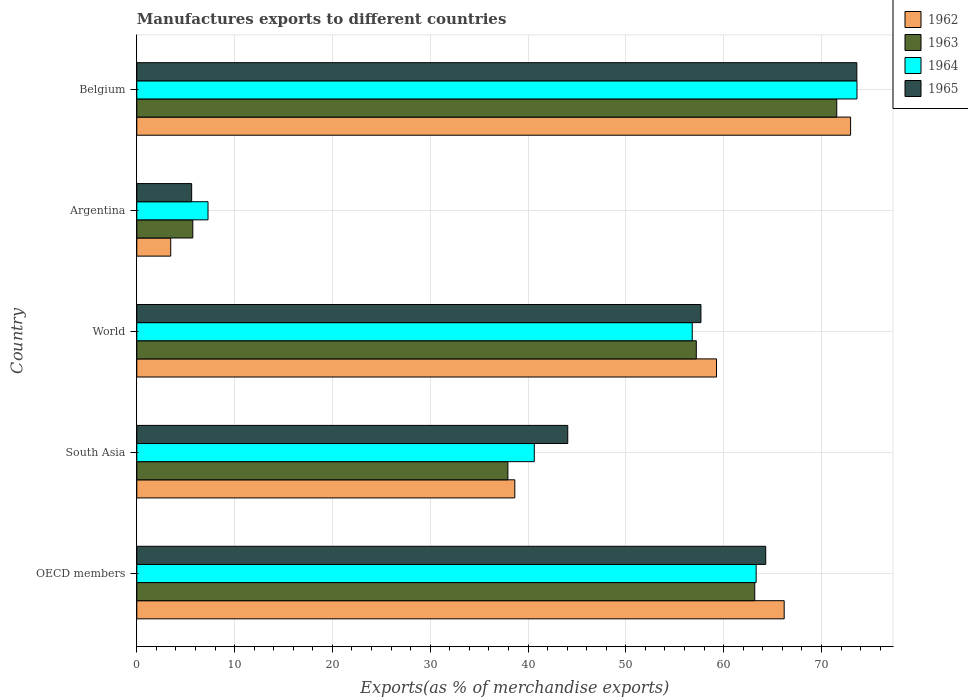How many different coloured bars are there?
Provide a succinct answer. 4. How many groups of bars are there?
Offer a very short reply. 5. Are the number of bars per tick equal to the number of legend labels?
Keep it short and to the point. Yes. How many bars are there on the 5th tick from the top?
Your answer should be compact. 4. How many bars are there on the 3rd tick from the bottom?
Your answer should be compact. 4. In how many cases, is the number of bars for a given country not equal to the number of legend labels?
Your response must be concise. 0. What is the percentage of exports to different countries in 1965 in Belgium?
Make the answer very short. 73.62. Across all countries, what is the maximum percentage of exports to different countries in 1963?
Give a very brief answer. 71.56. Across all countries, what is the minimum percentage of exports to different countries in 1964?
Give a very brief answer. 7.28. In which country was the percentage of exports to different countries in 1965 minimum?
Make the answer very short. Argentina. What is the total percentage of exports to different countries in 1964 in the graph?
Make the answer very short. 241.67. What is the difference between the percentage of exports to different countries in 1963 in Argentina and that in South Asia?
Your answer should be very brief. -32.21. What is the difference between the percentage of exports to different countries in 1965 in OECD members and the percentage of exports to different countries in 1964 in Argentina?
Offer a terse response. 57.02. What is the average percentage of exports to different countries in 1964 per country?
Offer a terse response. 48.33. What is the difference between the percentage of exports to different countries in 1962 and percentage of exports to different countries in 1965 in Belgium?
Ensure brevity in your answer.  -0.64. In how many countries, is the percentage of exports to different countries in 1965 greater than 22 %?
Offer a terse response. 4. What is the ratio of the percentage of exports to different countries in 1962 in Belgium to that in World?
Your response must be concise. 1.23. Is the difference between the percentage of exports to different countries in 1962 in Argentina and OECD members greater than the difference between the percentage of exports to different countries in 1965 in Argentina and OECD members?
Keep it short and to the point. No. What is the difference between the highest and the second highest percentage of exports to different countries in 1962?
Make the answer very short. 6.79. What is the difference between the highest and the lowest percentage of exports to different countries in 1963?
Give a very brief answer. 65.84. In how many countries, is the percentage of exports to different countries in 1962 greater than the average percentage of exports to different countries in 1962 taken over all countries?
Ensure brevity in your answer.  3. Is it the case that in every country, the sum of the percentage of exports to different countries in 1962 and percentage of exports to different countries in 1964 is greater than the sum of percentage of exports to different countries in 1965 and percentage of exports to different countries in 1963?
Keep it short and to the point. No. What does the 2nd bar from the top in Argentina represents?
Make the answer very short. 1964. What does the 4th bar from the bottom in OECD members represents?
Provide a succinct answer. 1965. Is it the case that in every country, the sum of the percentage of exports to different countries in 1963 and percentage of exports to different countries in 1962 is greater than the percentage of exports to different countries in 1964?
Give a very brief answer. Yes. Are all the bars in the graph horizontal?
Ensure brevity in your answer.  Yes. How many countries are there in the graph?
Offer a very short reply. 5. What is the difference between two consecutive major ticks on the X-axis?
Keep it short and to the point. 10. Are the values on the major ticks of X-axis written in scientific E-notation?
Offer a very short reply. No. Does the graph contain grids?
Give a very brief answer. Yes. Where does the legend appear in the graph?
Ensure brevity in your answer.  Top right. What is the title of the graph?
Ensure brevity in your answer.  Manufactures exports to different countries. Does "2002" appear as one of the legend labels in the graph?
Give a very brief answer. No. What is the label or title of the X-axis?
Offer a very short reply. Exports(as % of merchandise exports). What is the label or title of the Y-axis?
Your answer should be very brief. Country. What is the Exports(as % of merchandise exports) in 1962 in OECD members?
Your answer should be very brief. 66.19. What is the Exports(as % of merchandise exports) of 1963 in OECD members?
Ensure brevity in your answer.  63.18. What is the Exports(as % of merchandise exports) of 1964 in OECD members?
Provide a short and direct response. 63.32. What is the Exports(as % of merchandise exports) in 1965 in OECD members?
Keep it short and to the point. 64.3. What is the Exports(as % of merchandise exports) of 1962 in South Asia?
Your answer should be compact. 38.65. What is the Exports(as % of merchandise exports) in 1963 in South Asia?
Provide a short and direct response. 37.94. What is the Exports(as % of merchandise exports) in 1964 in South Asia?
Your response must be concise. 40.64. What is the Exports(as % of merchandise exports) in 1965 in South Asia?
Keep it short and to the point. 44.06. What is the Exports(as % of merchandise exports) of 1962 in World?
Provide a short and direct response. 59.27. What is the Exports(as % of merchandise exports) in 1963 in World?
Offer a terse response. 57.2. What is the Exports(as % of merchandise exports) of 1964 in World?
Your response must be concise. 56.79. What is the Exports(as % of merchandise exports) of 1965 in World?
Keep it short and to the point. 57.68. What is the Exports(as % of merchandise exports) of 1962 in Argentina?
Ensure brevity in your answer.  3.47. What is the Exports(as % of merchandise exports) in 1963 in Argentina?
Provide a short and direct response. 5.73. What is the Exports(as % of merchandise exports) of 1964 in Argentina?
Offer a very short reply. 7.28. What is the Exports(as % of merchandise exports) in 1965 in Argentina?
Your response must be concise. 5.61. What is the Exports(as % of merchandise exports) in 1962 in Belgium?
Provide a short and direct response. 72.98. What is the Exports(as % of merchandise exports) in 1963 in Belgium?
Provide a short and direct response. 71.56. What is the Exports(as % of merchandise exports) of 1964 in Belgium?
Your response must be concise. 73.63. What is the Exports(as % of merchandise exports) in 1965 in Belgium?
Make the answer very short. 73.62. Across all countries, what is the maximum Exports(as % of merchandise exports) of 1962?
Provide a short and direct response. 72.98. Across all countries, what is the maximum Exports(as % of merchandise exports) in 1963?
Provide a short and direct response. 71.56. Across all countries, what is the maximum Exports(as % of merchandise exports) in 1964?
Offer a terse response. 73.63. Across all countries, what is the maximum Exports(as % of merchandise exports) of 1965?
Offer a terse response. 73.62. Across all countries, what is the minimum Exports(as % of merchandise exports) of 1962?
Ensure brevity in your answer.  3.47. Across all countries, what is the minimum Exports(as % of merchandise exports) in 1963?
Provide a short and direct response. 5.73. Across all countries, what is the minimum Exports(as % of merchandise exports) in 1964?
Your response must be concise. 7.28. Across all countries, what is the minimum Exports(as % of merchandise exports) of 1965?
Offer a very short reply. 5.61. What is the total Exports(as % of merchandise exports) in 1962 in the graph?
Make the answer very short. 240.56. What is the total Exports(as % of merchandise exports) of 1963 in the graph?
Keep it short and to the point. 235.61. What is the total Exports(as % of merchandise exports) in 1964 in the graph?
Keep it short and to the point. 241.67. What is the total Exports(as % of merchandise exports) in 1965 in the graph?
Make the answer very short. 245.27. What is the difference between the Exports(as % of merchandise exports) in 1962 in OECD members and that in South Asia?
Offer a terse response. 27.54. What is the difference between the Exports(as % of merchandise exports) of 1963 in OECD members and that in South Asia?
Offer a very short reply. 25.24. What is the difference between the Exports(as % of merchandise exports) in 1964 in OECD members and that in South Asia?
Your answer should be very brief. 22.68. What is the difference between the Exports(as % of merchandise exports) of 1965 in OECD members and that in South Asia?
Offer a very short reply. 20.24. What is the difference between the Exports(as % of merchandise exports) of 1962 in OECD members and that in World?
Your response must be concise. 6.92. What is the difference between the Exports(as % of merchandise exports) of 1963 in OECD members and that in World?
Give a very brief answer. 5.98. What is the difference between the Exports(as % of merchandise exports) of 1964 in OECD members and that in World?
Your answer should be compact. 6.53. What is the difference between the Exports(as % of merchandise exports) in 1965 in OECD members and that in World?
Offer a terse response. 6.63. What is the difference between the Exports(as % of merchandise exports) in 1962 in OECD members and that in Argentina?
Offer a terse response. 62.72. What is the difference between the Exports(as % of merchandise exports) of 1963 in OECD members and that in Argentina?
Your response must be concise. 57.46. What is the difference between the Exports(as % of merchandise exports) of 1964 in OECD members and that in Argentina?
Keep it short and to the point. 56.04. What is the difference between the Exports(as % of merchandise exports) of 1965 in OECD members and that in Argentina?
Offer a terse response. 58.69. What is the difference between the Exports(as % of merchandise exports) of 1962 in OECD members and that in Belgium?
Provide a succinct answer. -6.79. What is the difference between the Exports(as % of merchandise exports) of 1963 in OECD members and that in Belgium?
Make the answer very short. -8.38. What is the difference between the Exports(as % of merchandise exports) in 1964 in OECD members and that in Belgium?
Offer a terse response. -10.31. What is the difference between the Exports(as % of merchandise exports) of 1965 in OECD members and that in Belgium?
Give a very brief answer. -9.32. What is the difference between the Exports(as % of merchandise exports) in 1962 in South Asia and that in World?
Keep it short and to the point. -20.62. What is the difference between the Exports(as % of merchandise exports) of 1963 in South Asia and that in World?
Give a very brief answer. -19.26. What is the difference between the Exports(as % of merchandise exports) of 1964 in South Asia and that in World?
Provide a succinct answer. -16.15. What is the difference between the Exports(as % of merchandise exports) of 1965 in South Asia and that in World?
Give a very brief answer. -13.62. What is the difference between the Exports(as % of merchandise exports) of 1962 in South Asia and that in Argentina?
Provide a short and direct response. 35.18. What is the difference between the Exports(as % of merchandise exports) of 1963 in South Asia and that in Argentina?
Your response must be concise. 32.21. What is the difference between the Exports(as % of merchandise exports) in 1964 in South Asia and that in Argentina?
Provide a short and direct response. 33.36. What is the difference between the Exports(as % of merchandise exports) of 1965 in South Asia and that in Argentina?
Offer a very short reply. 38.45. What is the difference between the Exports(as % of merchandise exports) in 1962 in South Asia and that in Belgium?
Make the answer very short. -34.33. What is the difference between the Exports(as % of merchandise exports) in 1963 in South Asia and that in Belgium?
Provide a succinct answer. -33.62. What is the difference between the Exports(as % of merchandise exports) in 1964 in South Asia and that in Belgium?
Offer a very short reply. -32.99. What is the difference between the Exports(as % of merchandise exports) in 1965 in South Asia and that in Belgium?
Make the answer very short. -29.56. What is the difference between the Exports(as % of merchandise exports) in 1962 in World and that in Argentina?
Offer a terse response. 55.8. What is the difference between the Exports(as % of merchandise exports) of 1963 in World and that in Argentina?
Provide a short and direct response. 51.48. What is the difference between the Exports(as % of merchandise exports) of 1964 in World and that in Argentina?
Offer a very short reply. 49.51. What is the difference between the Exports(as % of merchandise exports) of 1965 in World and that in Argentina?
Offer a terse response. 52.07. What is the difference between the Exports(as % of merchandise exports) in 1962 in World and that in Belgium?
Provide a short and direct response. -13.71. What is the difference between the Exports(as % of merchandise exports) in 1963 in World and that in Belgium?
Offer a terse response. -14.36. What is the difference between the Exports(as % of merchandise exports) in 1964 in World and that in Belgium?
Provide a short and direct response. -16.84. What is the difference between the Exports(as % of merchandise exports) of 1965 in World and that in Belgium?
Your response must be concise. -15.94. What is the difference between the Exports(as % of merchandise exports) in 1962 in Argentina and that in Belgium?
Make the answer very short. -69.51. What is the difference between the Exports(as % of merchandise exports) in 1963 in Argentina and that in Belgium?
Provide a short and direct response. -65.84. What is the difference between the Exports(as % of merchandise exports) of 1964 in Argentina and that in Belgium?
Offer a very short reply. -66.35. What is the difference between the Exports(as % of merchandise exports) of 1965 in Argentina and that in Belgium?
Your answer should be compact. -68.01. What is the difference between the Exports(as % of merchandise exports) in 1962 in OECD members and the Exports(as % of merchandise exports) in 1963 in South Asia?
Ensure brevity in your answer.  28.25. What is the difference between the Exports(as % of merchandise exports) of 1962 in OECD members and the Exports(as % of merchandise exports) of 1964 in South Asia?
Offer a very short reply. 25.55. What is the difference between the Exports(as % of merchandise exports) of 1962 in OECD members and the Exports(as % of merchandise exports) of 1965 in South Asia?
Your response must be concise. 22.13. What is the difference between the Exports(as % of merchandise exports) of 1963 in OECD members and the Exports(as % of merchandise exports) of 1964 in South Asia?
Make the answer very short. 22.54. What is the difference between the Exports(as % of merchandise exports) in 1963 in OECD members and the Exports(as % of merchandise exports) in 1965 in South Asia?
Give a very brief answer. 19.12. What is the difference between the Exports(as % of merchandise exports) of 1964 in OECD members and the Exports(as % of merchandise exports) of 1965 in South Asia?
Make the answer very short. 19.26. What is the difference between the Exports(as % of merchandise exports) of 1962 in OECD members and the Exports(as % of merchandise exports) of 1963 in World?
Give a very brief answer. 8.99. What is the difference between the Exports(as % of merchandise exports) of 1962 in OECD members and the Exports(as % of merchandise exports) of 1964 in World?
Offer a terse response. 9.4. What is the difference between the Exports(as % of merchandise exports) of 1962 in OECD members and the Exports(as % of merchandise exports) of 1965 in World?
Your answer should be very brief. 8.51. What is the difference between the Exports(as % of merchandise exports) of 1963 in OECD members and the Exports(as % of merchandise exports) of 1964 in World?
Provide a short and direct response. 6.39. What is the difference between the Exports(as % of merchandise exports) in 1963 in OECD members and the Exports(as % of merchandise exports) in 1965 in World?
Your answer should be very brief. 5.5. What is the difference between the Exports(as % of merchandise exports) in 1964 in OECD members and the Exports(as % of merchandise exports) in 1965 in World?
Make the answer very short. 5.65. What is the difference between the Exports(as % of merchandise exports) in 1962 in OECD members and the Exports(as % of merchandise exports) in 1963 in Argentina?
Your answer should be compact. 60.46. What is the difference between the Exports(as % of merchandise exports) of 1962 in OECD members and the Exports(as % of merchandise exports) of 1964 in Argentina?
Give a very brief answer. 58.91. What is the difference between the Exports(as % of merchandise exports) of 1962 in OECD members and the Exports(as % of merchandise exports) of 1965 in Argentina?
Your answer should be compact. 60.58. What is the difference between the Exports(as % of merchandise exports) in 1963 in OECD members and the Exports(as % of merchandise exports) in 1964 in Argentina?
Your response must be concise. 55.9. What is the difference between the Exports(as % of merchandise exports) of 1963 in OECD members and the Exports(as % of merchandise exports) of 1965 in Argentina?
Your response must be concise. 57.57. What is the difference between the Exports(as % of merchandise exports) of 1964 in OECD members and the Exports(as % of merchandise exports) of 1965 in Argentina?
Ensure brevity in your answer.  57.71. What is the difference between the Exports(as % of merchandise exports) in 1962 in OECD members and the Exports(as % of merchandise exports) in 1963 in Belgium?
Your response must be concise. -5.37. What is the difference between the Exports(as % of merchandise exports) in 1962 in OECD members and the Exports(as % of merchandise exports) in 1964 in Belgium?
Make the answer very short. -7.44. What is the difference between the Exports(as % of merchandise exports) in 1962 in OECD members and the Exports(as % of merchandise exports) in 1965 in Belgium?
Offer a very short reply. -7.43. What is the difference between the Exports(as % of merchandise exports) in 1963 in OECD members and the Exports(as % of merchandise exports) in 1964 in Belgium?
Your response must be concise. -10.45. What is the difference between the Exports(as % of merchandise exports) of 1963 in OECD members and the Exports(as % of merchandise exports) of 1965 in Belgium?
Give a very brief answer. -10.44. What is the difference between the Exports(as % of merchandise exports) of 1964 in OECD members and the Exports(as % of merchandise exports) of 1965 in Belgium?
Offer a terse response. -10.29. What is the difference between the Exports(as % of merchandise exports) of 1962 in South Asia and the Exports(as % of merchandise exports) of 1963 in World?
Your answer should be compact. -18.56. What is the difference between the Exports(as % of merchandise exports) of 1962 in South Asia and the Exports(as % of merchandise exports) of 1964 in World?
Your answer should be compact. -18.14. What is the difference between the Exports(as % of merchandise exports) of 1962 in South Asia and the Exports(as % of merchandise exports) of 1965 in World?
Your answer should be compact. -19.03. What is the difference between the Exports(as % of merchandise exports) in 1963 in South Asia and the Exports(as % of merchandise exports) in 1964 in World?
Provide a short and direct response. -18.85. What is the difference between the Exports(as % of merchandise exports) of 1963 in South Asia and the Exports(as % of merchandise exports) of 1965 in World?
Keep it short and to the point. -19.74. What is the difference between the Exports(as % of merchandise exports) in 1964 in South Asia and the Exports(as % of merchandise exports) in 1965 in World?
Ensure brevity in your answer.  -17.04. What is the difference between the Exports(as % of merchandise exports) in 1962 in South Asia and the Exports(as % of merchandise exports) in 1963 in Argentina?
Your answer should be compact. 32.92. What is the difference between the Exports(as % of merchandise exports) of 1962 in South Asia and the Exports(as % of merchandise exports) of 1964 in Argentina?
Your answer should be compact. 31.37. What is the difference between the Exports(as % of merchandise exports) of 1962 in South Asia and the Exports(as % of merchandise exports) of 1965 in Argentina?
Keep it short and to the point. 33.04. What is the difference between the Exports(as % of merchandise exports) of 1963 in South Asia and the Exports(as % of merchandise exports) of 1964 in Argentina?
Offer a terse response. 30.66. What is the difference between the Exports(as % of merchandise exports) of 1963 in South Asia and the Exports(as % of merchandise exports) of 1965 in Argentina?
Keep it short and to the point. 32.33. What is the difference between the Exports(as % of merchandise exports) of 1964 in South Asia and the Exports(as % of merchandise exports) of 1965 in Argentina?
Offer a terse response. 35.03. What is the difference between the Exports(as % of merchandise exports) of 1962 in South Asia and the Exports(as % of merchandise exports) of 1963 in Belgium?
Offer a terse response. -32.92. What is the difference between the Exports(as % of merchandise exports) in 1962 in South Asia and the Exports(as % of merchandise exports) in 1964 in Belgium?
Your response must be concise. -34.98. What is the difference between the Exports(as % of merchandise exports) in 1962 in South Asia and the Exports(as % of merchandise exports) in 1965 in Belgium?
Offer a terse response. -34.97. What is the difference between the Exports(as % of merchandise exports) of 1963 in South Asia and the Exports(as % of merchandise exports) of 1964 in Belgium?
Offer a very short reply. -35.69. What is the difference between the Exports(as % of merchandise exports) in 1963 in South Asia and the Exports(as % of merchandise exports) in 1965 in Belgium?
Provide a succinct answer. -35.68. What is the difference between the Exports(as % of merchandise exports) of 1964 in South Asia and the Exports(as % of merchandise exports) of 1965 in Belgium?
Ensure brevity in your answer.  -32.98. What is the difference between the Exports(as % of merchandise exports) of 1962 in World and the Exports(as % of merchandise exports) of 1963 in Argentina?
Your answer should be compact. 53.55. What is the difference between the Exports(as % of merchandise exports) in 1962 in World and the Exports(as % of merchandise exports) in 1964 in Argentina?
Provide a succinct answer. 51.99. What is the difference between the Exports(as % of merchandise exports) in 1962 in World and the Exports(as % of merchandise exports) in 1965 in Argentina?
Your answer should be very brief. 53.66. What is the difference between the Exports(as % of merchandise exports) of 1963 in World and the Exports(as % of merchandise exports) of 1964 in Argentina?
Offer a terse response. 49.92. What is the difference between the Exports(as % of merchandise exports) of 1963 in World and the Exports(as % of merchandise exports) of 1965 in Argentina?
Your answer should be compact. 51.59. What is the difference between the Exports(as % of merchandise exports) in 1964 in World and the Exports(as % of merchandise exports) in 1965 in Argentina?
Keep it short and to the point. 51.18. What is the difference between the Exports(as % of merchandise exports) in 1962 in World and the Exports(as % of merchandise exports) in 1963 in Belgium?
Your answer should be compact. -12.29. What is the difference between the Exports(as % of merchandise exports) of 1962 in World and the Exports(as % of merchandise exports) of 1964 in Belgium?
Provide a short and direct response. -14.36. What is the difference between the Exports(as % of merchandise exports) in 1962 in World and the Exports(as % of merchandise exports) in 1965 in Belgium?
Make the answer very short. -14.35. What is the difference between the Exports(as % of merchandise exports) of 1963 in World and the Exports(as % of merchandise exports) of 1964 in Belgium?
Ensure brevity in your answer.  -16.43. What is the difference between the Exports(as % of merchandise exports) in 1963 in World and the Exports(as % of merchandise exports) in 1965 in Belgium?
Give a very brief answer. -16.41. What is the difference between the Exports(as % of merchandise exports) of 1964 in World and the Exports(as % of merchandise exports) of 1965 in Belgium?
Offer a very short reply. -16.83. What is the difference between the Exports(as % of merchandise exports) in 1962 in Argentina and the Exports(as % of merchandise exports) in 1963 in Belgium?
Provide a succinct answer. -68.1. What is the difference between the Exports(as % of merchandise exports) in 1962 in Argentina and the Exports(as % of merchandise exports) in 1964 in Belgium?
Provide a short and direct response. -70.16. What is the difference between the Exports(as % of merchandise exports) in 1962 in Argentina and the Exports(as % of merchandise exports) in 1965 in Belgium?
Your answer should be compact. -70.15. What is the difference between the Exports(as % of merchandise exports) in 1963 in Argentina and the Exports(as % of merchandise exports) in 1964 in Belgium?
Offer a very short reply. -67.91. What is the difference between the Exports(as % of merchandise exports) in 1963 in Argentina and the Exports(as % of merchandise exports) in 1965 in Belgium?
Your response must be concise. -67.89. What is the difference between the Exports(as % of merchandise exports) in 1964 in Argentina and the Exports(as % of merchandise exports) in 1965 in Belgium?
Give a very brief answer. -66.33. What is the average Exports(as % of merchandise exports) in 1962 per country?
Offer a terse response. 48.11. What is the average Exports(as % of merchandise exports) in 1963 per country?
Provide a succinct answer. 47.12. What is the average Exports(as % of merchandise exports) in 1964 per country?
Your response must be concise. 48.33. What is the average Exports(as % of merchandise exports) in 1965 per country?
Your answer should be compact. 49.05. What is the difference between the Exports(as % of merchandise exports) in 1962 and Exports(as % of merchandise exports) in 1963 in OECD members?
Offer a very short reply. 3.01. What is the difference between the Exports(as % of merchandise exports) in 1962 and Exports(as % of merchandise exports) in 1964 in OECD members?
Offer a very short reply. 2.87. What is the difference between the Exports(as % of merchandise exports) in 1962 and Exports(as % of merchandise exports) in 1965 in OECD members?
Offer a very short reply. 1.89. What is the difference between the Exports(as % of merchandise exports) of 1963 and Exports(as % of merchandise exports) of 1964 in OECD members?
Keep it short and to the point. -0.14. What is the difference between the Exports(as % of merchandise exports) in 1963 and Exports(as % of merchandise exports) in 1965 in OECD members?
Offer a terse response. -1.12. What is the difference between the Exports(as % of merchandise exports) in 1964 and Exports(as % of merchandise exports) in 1965 in OECD members?
Your answer should be very brief. -0.98. What is the difference between the Exports(as % of merchandise exports) in 1962 and Exports(as % of merchandise exports) in 1963 in South Asia?
Give a very brief answer. 0.71. What is the difference between the Exports(as % of merchandise exports) in 1962 and Exports(as % of merchandise exports) in 1964 in South Asia?
Offer a very short reply. -1.99. What is the difference between the Exports(as % of merchandise exports) of 1962 and Exports(as % of merchandise exports) of 1965 in South Asia?
Your answer should be compact. -5.41. What is the difference between the Exports(as % of merchandise exports) in 1963 and Exports(as % of merchandise exports) in 1964 in South Asia?
Your answer should be compact. -2.7. What is the difference between the Exports(as % of merchandise exports) in 1963 and Exports(as % of merchandise exports) in 1965 in South Asia?
Keep it short and to the point. -6.12. What is the difference between the Exports(as % of merchandise exports) of 1964 and Exports(as % of merchandise exports) of 1965 in South Asia?
Your answer should be very brief. -3.42. What is the difference between the Exports(as % of merchandise exports) of 1962 and Exports(as % of merchandise exports) of 1963 in World?
Provide a short and direct response. 2.07. What is the difference between the Exports(as % of merchandise exports) of 1962 and Exports(as % of merchandise exports) of 1964 in World?
Ensure brevity in your answer.  2.48. What is the difference between the Exports(as % of merchandise exports) of 1962 and Exports(as % of merchandise exports) of 1965 in World?
Your answer should be very brief. 1.59. What is the difference between the Exports(as % of merchandise exports) in 1963 and Exports(as % of merchandise exports) in 1964 in World?
Keep it short and to the point. 0.41. What is the difference between the Exports(as % of merchandise exports) of 1963 and Exports(as % of merchandise exports) of 1965 in World?
Ensure brevity in your answer.  -0.47. What is the difference between the Exports(as % of merchandise exports) of 1964 and Exports(as % of merchandise exports) of 1965 in World?
Make the answer very short. -0.89. What is the difference between the Exports(as % of merchandise exports) of 1962 and Exports(as % of merchandise exports) of 1963 in Argentina?
Your answer should be very brief. -2.26. What is the difference between the Exports(as % of merchandise exports) of 1962 and Exports(as % of merchandise exports) of 1964 in Argentina?
Keep it short and to the point. -3.81. What is the difference between the Exports(as % of merchandise exports) in 1962 and Exports(as % of merchandise exports) in 1965 in Argentina?
Make the answer very short. -2.14. What is the difference between the Exports(as % of merchandise exports) of 1963 and Exports(as % of merchandise exports) of 1964 in Argentina?
Keep it short and to the point. -1.56. What is the difference between the Exports(as % of merchandise exports) in 1963 and Exports(as % of merchandise exports) in 1965 in Argentina?
Keep it short and to the point. 0.12. What is the difference between the Exports(as % of merchandise exports) of 1964 and Exports(as % of merchandise exports) of 1965 in Argentina?
Offer a terse response. 1.67. What is the difference between the Exports(as % of merchandise exports) of 1962 and Exports(as % of merchandise exports) of 1963 in Belgium?
Make the answer very short. 1.42. What is the difference between the Exports(as % of merchandise exports) in 1962 and Exports(as % of merchandise exports) in 1964 in Belgium?
Make the answer very short. -0.65. What is the difference between the Exports(as % of merchandise exports) in 1962 and Exports(as % of merchandise exports) in 1965 in Belgium?
Keep it short and to the point. -0.64. What is the difference between the Exports(as % of merchandise exports) of 1963 and Exports(as % of merchandise exports) of 1964 in Belgium?
Offer a very short reply. -2.07. What is the difference between the Exports(as % of merchandise exports) of 1963 and Exports(as % of merchandise exports) of 1965 in Belgium?
Offer a very short reply. -2.05. What is the difference between the Exports(as % of merchandise exports) of 1964 and Exports(as % of merchandise exports) of 1965 in Belgium?
Provide a short and direct response. 0.02. What is the ratio of the Exports(as % of merchandise exports) in 1962 in OECD members to that in South Asia?
Give a very brief answer. 1.71. What is the ratio of the Exports(as % of merchandise exports) of 1963 in OECD members to that in South Asia?
Your answer should be very brief. 1.67. What is the ratio of the Exports(as % of merchandise exports) in 1964 in OECD members to that in South Asia?
Make the answer very short. 1.56. What is the ratio of the Exports(as % of merchandise exports) of 1965 in OECD members to that in South Asia?
Keep it short and to the point. 1.46. What is the ratio of the Exports(as % of merchandise exports) in 1962 in OECD members to that in World?
Ensure brevity in your answer.  1.12. What is the ratio of the Exports(as % of merchandise exports) of 1963 in OECD members to that in World?
Give a very brief answer. 1.1. What is the ratio of the Exports(as % of merchandise exports) in 1964 in OECD members to that in World?
Your answer should be compact. 1.12. What is the ratio of the Exports(as % of merchandise exports) in 1965 in OECD members to that in World?
Make the answer very short. 1.11. What is the ratio of the Exports(as % of merchandise exports) in 1962 in OECD members to that in Argentina?
Offer a terse response. 19.09. What is the ratio of the Exports(as % of merchandise exports) of 1963 in OECD members to that in Argentina?
Your answer should be very brief. 11.03. What is the ratio of the Exports(as % of merchandise exports) in 1964 in OECD members to that in Argentina?
Ensure brevity in your answer.  8.7. What is the ratio of the Exports(as % of merchandise exports) of 1965 in OECD members to that in Argentina?
Keep it short and to the point. 11.46. What is the ratio of the Exports(as % of merchandise exports) of 1962 in OECD members to that in Belgium?
Your response must be concise. 0.91. What is the ratio of the Exports(as % of merchandise exports) in 1963 in OECD members to that in Belgium?
Make the answer very short. 0.88. What is the ratio of the Exports(as % of merchandise exports) in 1964 in OECD members to that in Belgium?
Your response must be concise. 0.86. What is the ratio of the Exports(as % of merchandise exports) in 1965 in OECD members to that in Belgium?
Make the answer very short. 0.87. What is the ratio of the Exports(as % of merchandise exports) in 1962 in South Asia to that in World?
Offer a very short reply. 0.65. What is the ratio of the Exports(as % of merchandise exports) of 1963 in South Asia to that in World?
Provide a succinct answer. 0.66. What is the ratio of the Exports(as % of merchandise exports) in 1964 in South Asia to that in World?
Offer a terse response. 0.72. What is the ratio of the Exports(as % of merchandise exports) of 1965 in South Asia to that in World?
Give a very brief answer. 0.76. What is the ratio of the Exports(as % of merchandise exports) of 1962 in South Asia to that in Argentina?
Your answer should be very brief. 11.14. What is the ratio of the Exports(as % of merchandise exports) in 1963 in South Asia to that in Argentina?
Provide a succinct answer. 6.63. What is the ratio of the Exports(as % of merchandise exports) in 1964 in South Asia to that in Argentina?
Offer a terse response. 5.58. What is the ratio of the Exports(as % of merchandise exports) in 1965 in South Asia to that in Argentina?
Keep it short and to the point. 7.86. What is the ratio of the Exports(as % of merchandise exports) in 1962 in South Asia to that in Belgium?
Provide a short and direct response. 0.53. What is the ratio of the Exports(as % of merchandise exports) of 1963 in South Asia to that in Belgium?
Your answer should be compact. 0.53. What is the ratio of the Exports(as % of merchandise exports) in 1964 in South Asia to that in Belgium?
Make the answer very short. 0.55. What is the ratio of the Exports(as % of merchandise exports) of 1965 in South Asia to that in Belgium?
Your response must be concise. 0.6. What is the ratio of the Exports(as % of merchandise exports) in 1962 in World to that in Argentina?
Provide a succinct answer. 17.09. What is the ratio of the Exports(as % of merchandise exports) of 1963 in World to that in Argentina?
Provide a succinct answer. 9.99. What is the ratio of the Exports(as % of merchandise exports) of 1964 in World to that in Argentina?
Give a very brief answer. 7.8. What is the ratio of the Exports(as % of merchandise exports) of 1965 in World to that in Argentina?
Give a very brief answer. 10.28. What is the ratio of the Exports(as % of merchandise exports) in 1962 in World to that in Belgium?
Ensure brevity in your answer.  0.81. What is the ratio of the Exports(as % of merchandise exports) of 1963 in World to that in Belgium?
Make the answer very short. 0.8. What is the ratio of the Exports(as % of merchandise exports) in 1964 in World to that in Belgium?
Your answer should be compact. 0.77. What is the ratio of the Exports(as % of merchandise exports) of 1965 in World to that in Belgium?
Give a very brief answer. 0.78. What is the ratio of the Exports(as % of merchandise exports) of 1962 in Argentina to that in Belgium?
Your answer should be compact. 0.05. What is the ratio of the Exports(as % of merchandise exports) of 1963 in Argentina to that in Belgium?
Provide a succinct answer. 0.08. What is the ratio of the Exports(as % of merchandise exports) in 1964 in Argentina to that in Belgium?
Ensure brevity in your answer.  0.1. What is the ratio of the Exports(as % of merchandise exports) of 1965 in Argentina to that in Belgium?
Provide a succinct answer. 0.08. What is the difference between the highest and the second highest Exports(as % of merchandise exports) of 1962?
Ensure brevity in your answer.  6.79. What is the difference between the highest and the second highest Exports(as % of merchandise exports) in 1963?
Your answer should be very brief. 8.38. What is the difference between the highest and the second highest Exports(as % of merchandise exports) in 1964?
Offer a terse response. 10.31. What is the difference between the highest and the second highest Exports(as % of merchandise exports) of 1965?
Your answer should be compact. 9.32. What is the difference between the highest and the lowest Exports(as % of merchandise exports) of 1962?
Keep it short and to the point. 69.51. What is the difference between the highest and the lowest Exports(as % of merchandise exports) in 1963?
Offer a terse response. 65.84. What is the difference between the highest and the lowest Exports(as % of merchandise exports) of 1964?
Offer a terse response. 66.35. What is the difference between the highest and the lowest Exports(as % of merchandise exports) of 1965?
Offer a terse response. 68.01. 